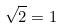Convert formula to latex. <formula><loc_0><loc_0><loc_500><loc_500>\sqrt { 2 } = 1</formula> 